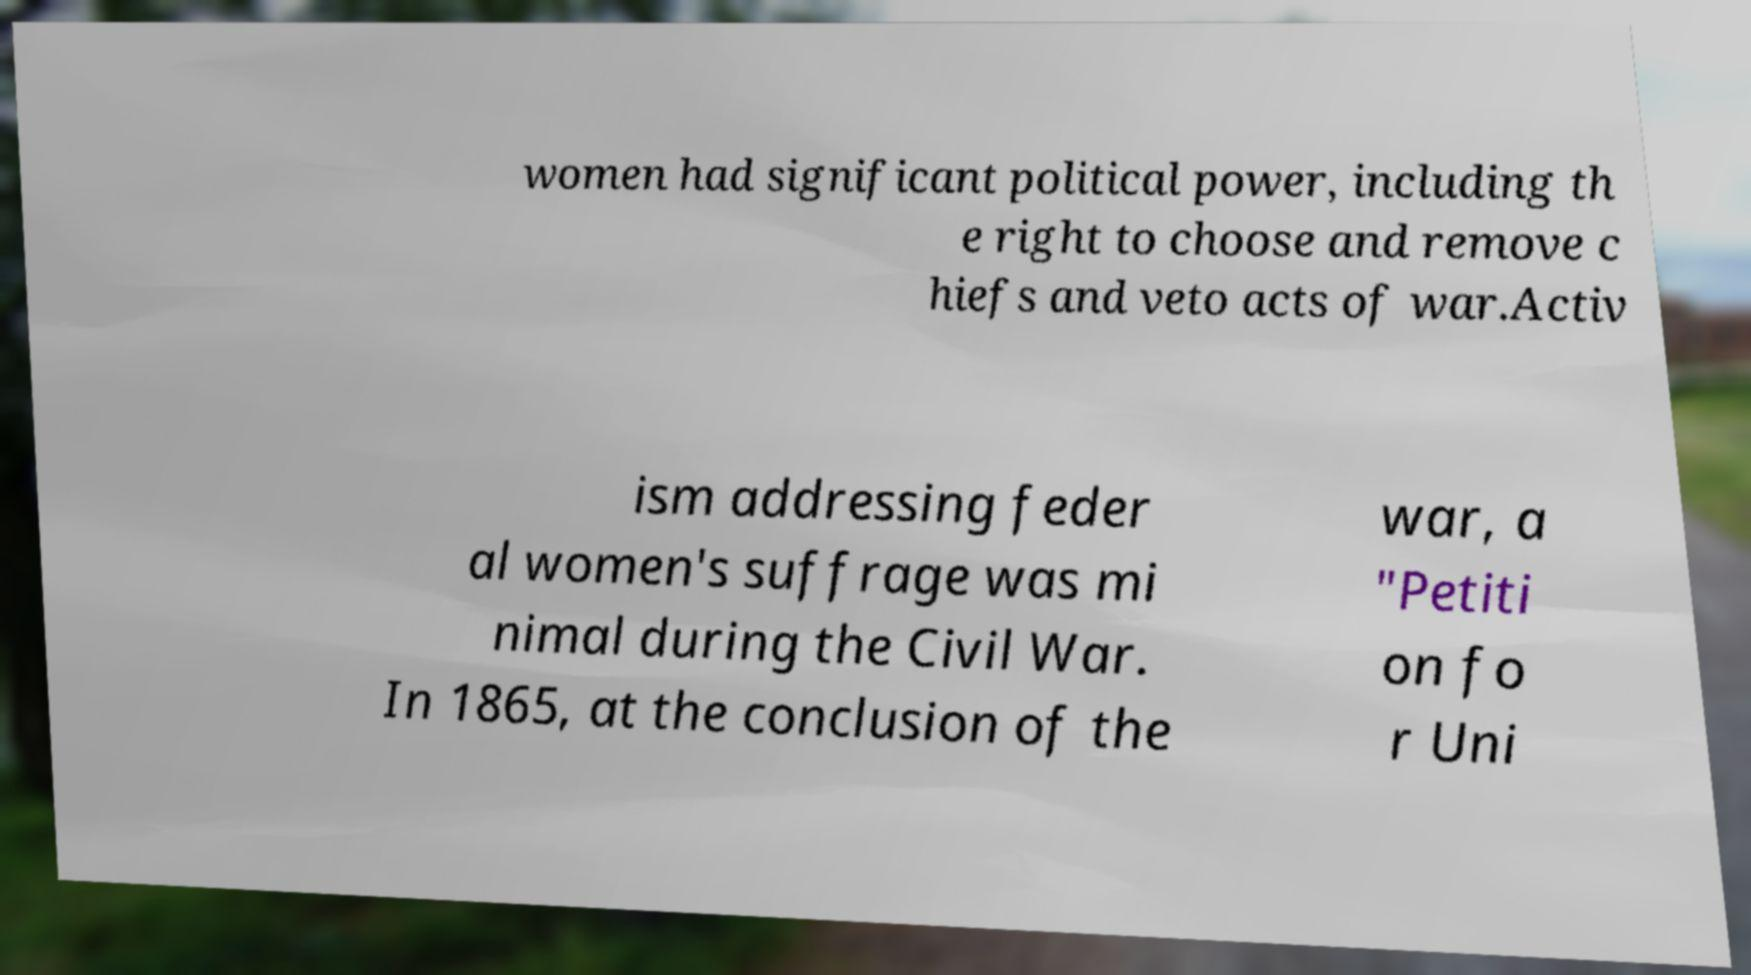Please identify and transcribe the text found in this image. women had significant political power, including th e right to choose and remove c hiefs and veto acts of war.Activ ism addressing feder al women's suffrage was mi nimal during the Civil War. In 1865, at the conclusion of the war, a "Petiti on fo r Uni 